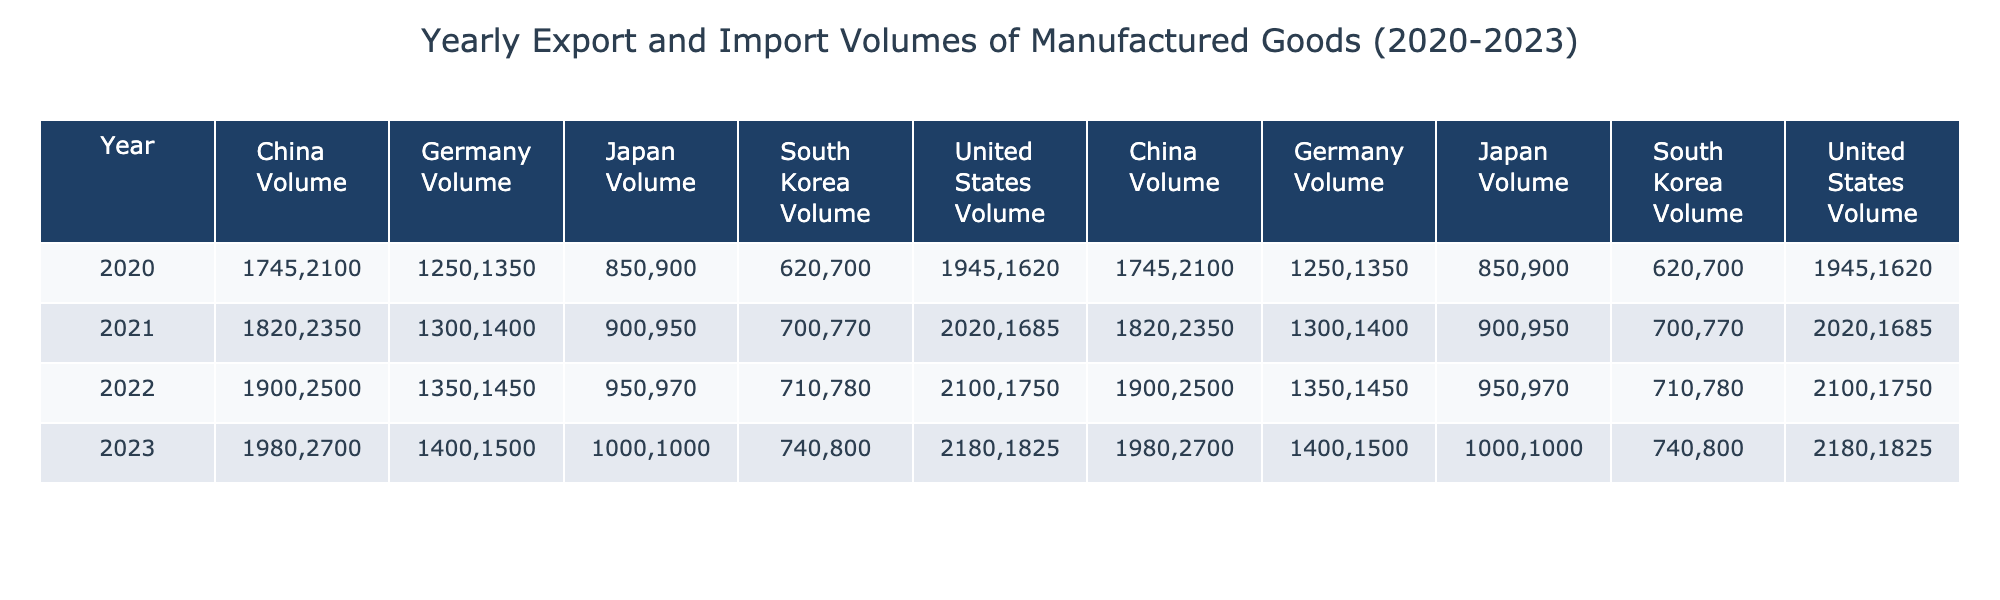What was the total export volume from China in 2021? To find the total export volume from China in 2021, we look at the table and see the value listed for China under the "Manufactured_Goods_Export_Volume" for that year, which is 2350.
Answer: 2350 What was the import volume of manufactured goods for the United States in 2022? The table lists the import volume for manufactured goods under "Manufactured_Goods_Import_Volume" for the United States in 2022, which is 2100.
Answer: 2100 Which country had the highest manufactured goods export volume in 2023? By comparing the export volumes in 2023 for each country, we see China had the highest export volume at 2700.
Answer: China What was the difference in export volumes for Japan between 2020 and 2023? The export volume for Japan in 2020 was 900, and in 2023 it was 1000. The difference is 1000 - 900 = 100.
Answer: 100 What was the average import volume of manufactured goods for South Korea from 2020 to 2023? First, we sum the import volumes over the four years: 620 (2020) + 700 (2021) + 710 (2022) + 740 (2023) = 2880. Then we divide by 4 to find the average: 2880 / 4 = 720.
Answer: 720 Was there a consistent increase in export volumes for the United States from 2020 to 2023? Checking the export volumes for the United States each year: 1620 (2020), 1685 (2021), 1750 (2022), 1825 (2023). Each year shows an increase, indicating a consistent rise in export volumes.
Answer: Yes What was the total import and export volume for Germany in 2022, and how does it compare to 2023? For Germany in 2022, the import volume was 1350 and the export volume was 1450, totaling 2800. In 2023, the import volume is 1400 and export volume is 1500, totaling 2900. The comparison shows that 2023 has a higher total by 100.
Answer: 2900, higher by 100 Which country saw the largest increase in manufactured goods import volume from 2020 to 2023? Reviewing the import volumes from 2020 to 2023: United States (1945 to 2180) = 235 increase, China (1745 to 1980) = 235 increase, Germany (1250 to 1400) = 150 increase, Japan (850 to 1000) = 150 increase, South Korea (620 to 740) = 120 increase. The largest increase is 235 for both the United States and China.
Answer: United States and China What is the trend in manufactured goods export volumes for Japan from 2020 to 2022? Export volumes for Japan are: 900 (2020), 950 (2021), and 970 (2022). Analyzing these values shows a consistent increase each year.
Answer: Increasing What was the import volume of manufactured goods for China in 2022 compared to 2021? The import volume for China was 1820 in 2021 and 1900 in 2022. Comparing these, we see an increase of 80.
Answer: Increased by 80 